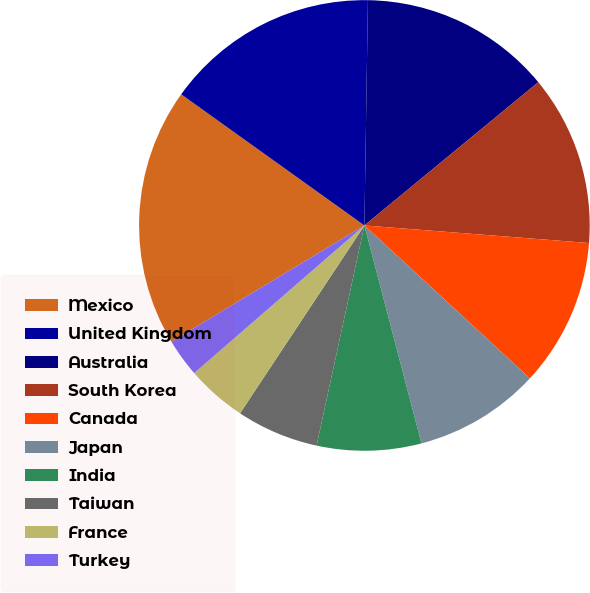<chart> <loc_0><loc_0><loc_500><loc_500><pie_chart><fcel>Mexico<fcel>United Kingdom<fcel>Australia<fcel>South Korea<fcel>Canada<fcel>Japan<fcel>India<fcel>Taiwan<fcel>France<fcel>Turkey<nl><fcel>18.51%<fcel>15.36%<fcel>13.78%<fcel>12.21%<fcel>10.63%<fcel>9.05%<fcel>7.48%<fcel>5.9%<fcel>4.32%<fcel>2.75%<nl></chart> 